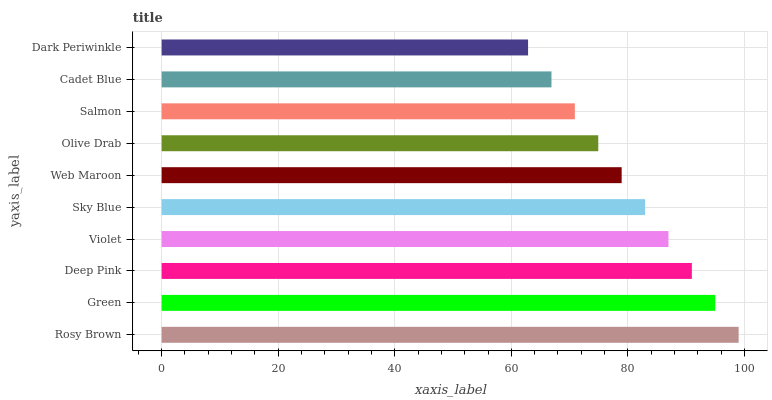Is Dark Periwinkle the minimum?
Answer yes or no. Yes. Is Rosy Brown the maximum?
Answer yes or no. Yes. Is Green the minimum?
Answer yes or no. No. Is Green the maximum?
Answer yes or no. No. Is Rosy Brown greater than Green?
Answer yes or no. Yes. Is Green less than Rosy Brown?
Answer yes or no. Yes. Is Green greater than Rosy Brown?
Answer yes or no. No. Is Rosy Brown less than Green?
Answer yes or no. No. Is Sky Blue the high median?
Answer yes or no. Yes. Is Web Maroon the low median?
Answer yes or no. Yes. Is Rosy Brown the high median?
Answer yes or no. No. Is Sky Blue the low median?
Answer yes or no. No. 